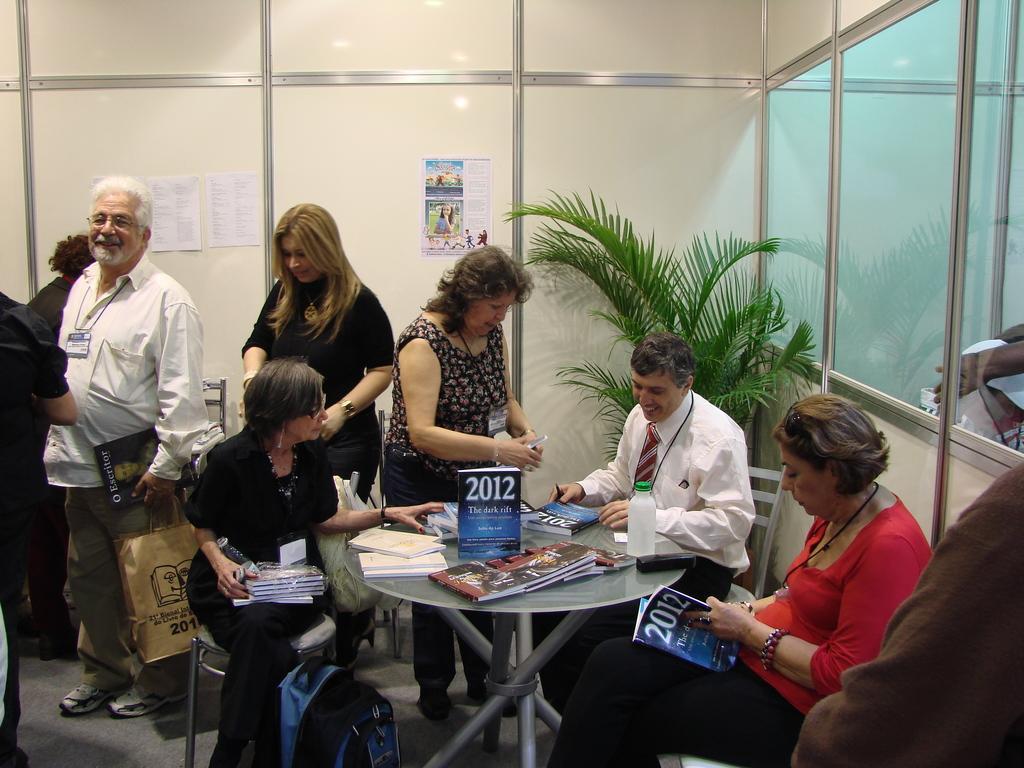Can you describe this image briefly? This is a picture taken in a room, there are a group of people sitting on a chair and some are standing on the floor. The man in white shirt holding a bag and a book. background of this people is a wall on the wall there are the papers. 